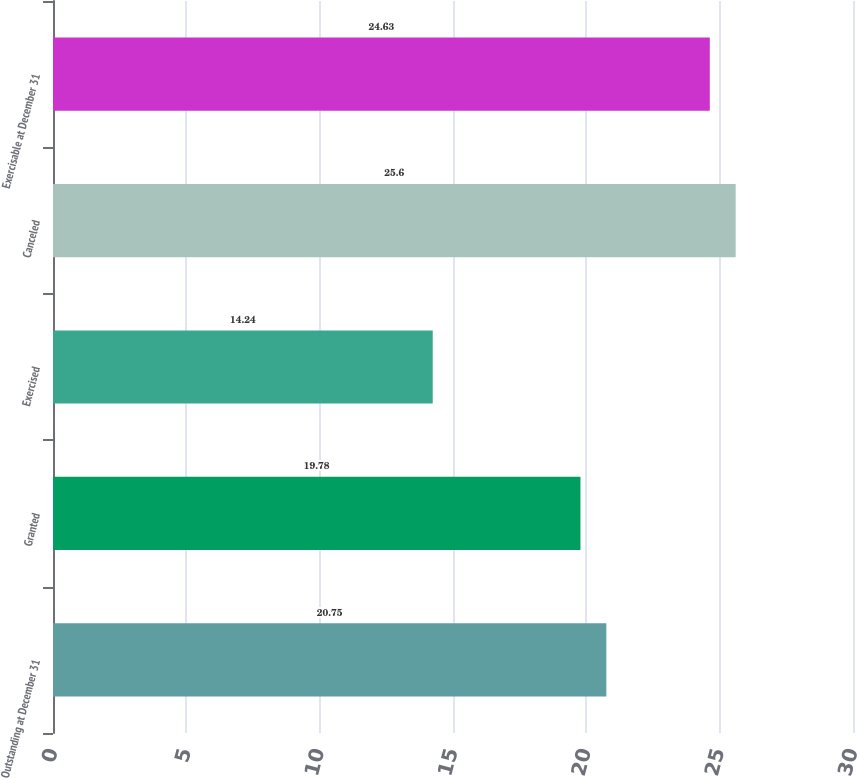<chart> <loc_0><loc_0><loc_500><loc_500><bar_chart><fcel>Outstanding at December 31<fcel>Granted<fcel>Exercised<fcel>Canceled<fcel>Exercisable at December 31<nl><fcel>20.75<fcel>19.78<fcel>14.24<fcel>25.6<fcel>24.63<nl></chart> 